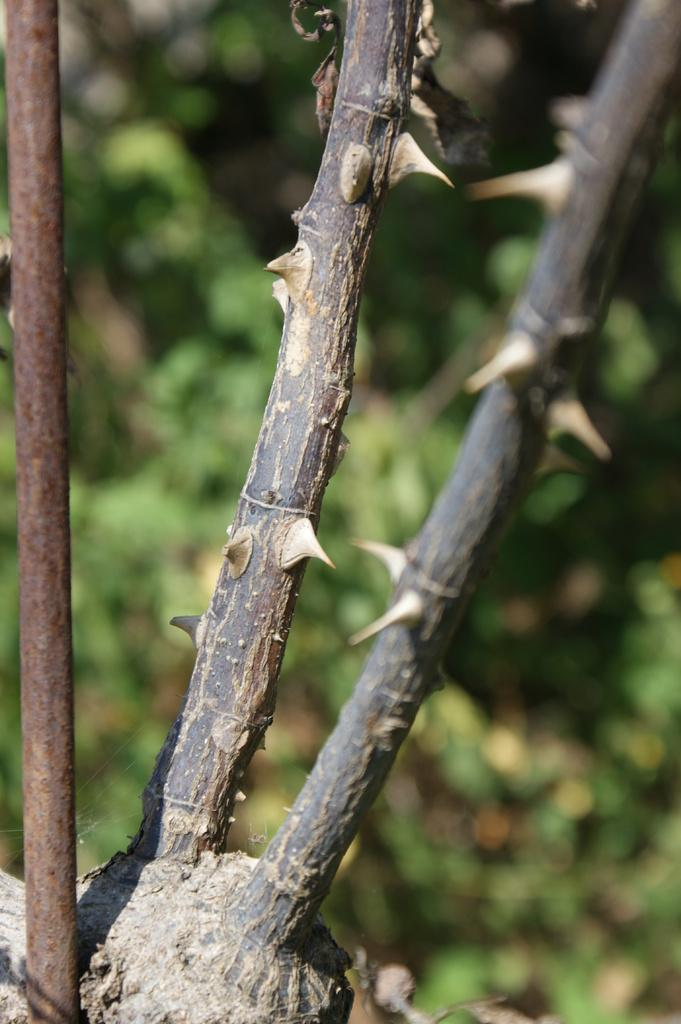What type of plants have thorns on their stems in the image? The facts do not specify the type of plants, only that there are thorns on the stems. What can be seen on the left side of the image? There is a pole on the left side of the image. How would you describe the background of the image? The background of the image is blurred. How does the rake provide support for the plants in the image? There is no rake present in the image, so it cannot provide support for the plants. 